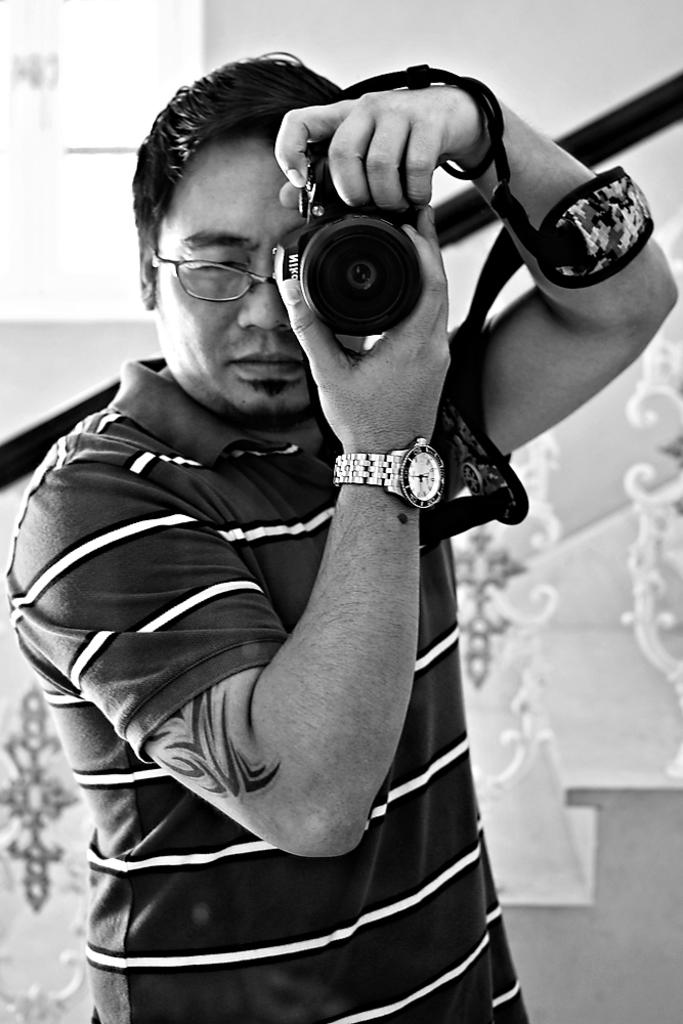What is the main subject of the image? There is a man in the image. What is the man holding in the image? The man is holding a camera. Can you see a snail crawling on the man's shoulder in the image? There is no snail present on the man's shoulder in the image. Is the man trying to smash something in the image? There is no indication in the image that the man is trying to smash anything. 